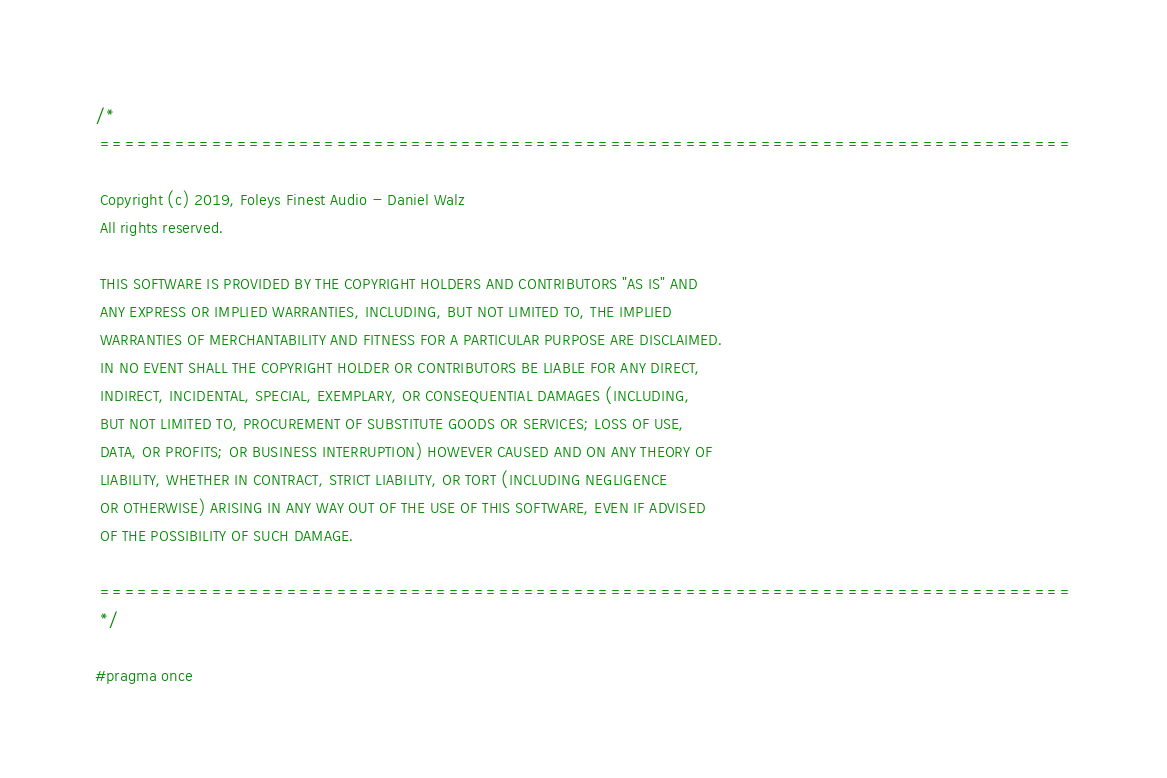<code> <loc_0><loc_0><loc_500><loc_500><_C_>/*
 ==============================================================================

 Copyright (c) 2019, Foleys Finest Audio - Daniel Walz
 All rights reserved.

 THIS SOFTWARE IS PROVIDED BY THE COPYRIGHT HOLDERS AND CONTRIBUTORS "AS IS" AND
 ANY EXPRESS OR IMPLIED WARRANTIES, INCLUDING, BUT NOT LIMITED TO, THE IMPLIED
 WARRANTIES OF MERCHANTABILITY AND FITNESS FOR A PARTICULAR PURPOSE ARE DISCLAIMED.
 IN NO EVENT SHALL THE COPYRIGHT HOLDER OR CONTRIBUTORS BE LIABLE FOR ANY DIRECT,
 INDIRECT, INCIDENTAL, SPECIAL, EXEMPLARY, OR CONSEQUENTIAL DAMAGES (INCLUDING,
 BUT NOT LIMITED TO, PROCUREMENT OF SUBSTITUTE GOODS OR SERVICES; LOSS OF USE,
 DATA, OR PROFITS; OR BUSINESS INTERRUPTION) HOWEVER CAUSED AND ON ANY THEORY OF
 LIABILITY, WHETHER IN CONTRACT, STRICT LIABILITY, OR TORT (INCLUDING NEGLIGENCE
 OR OTHERWISE) ARISING IN ANY WAY OUT OF THE USE OF THIS SOFTWARE, EVEN IF ADVISED
 OF THE POSSIBILITY OF SUCH DAMAGE.

 ==============================================================================
 */

#pragma once
</code> 